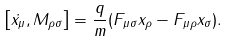Convert formula to latex. <formula><loc_0><loc_0><loc_500><loc_500>\left [ \dot { x } _ { \mu } , M _ { \rho \sigma } \right ] = \frac { q } { m } ( F _ { \mu \sigma } x _ { \rho } - F _ { \mu \rho } x _ { \sigma } ) .</formula> 